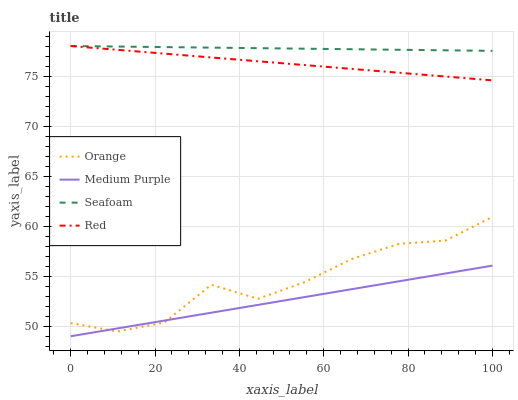Does Medium Purple have the minimum area under the curve?
Answer yes or no. Yes. Does Seafoam have the maximum area under the curve?
Answer yes or no. Yes. Does Seafoam have the minimum area under the curve?
Answer yes or no. No. Does Medium Purple have the maximum area under the curve?
Answer yes or no. No. Is Seafoam the smoothest?
Answer yes or no. Yes. Is Orange the roughest?
Answer yes or no. Yes. Is Medium Purple the smoothest?
Answer yes or no. No. Is Medium Purple the roughest?
Answer yes or no. No. Does Seafoam have the lowest value?
Answer yes or no. No. Does Red have the highest value?
Answer yes or no. Yes. Does Medium Purple have the highest value?
Answer yes or no. No. Is Medium Purple less than Seafoam?
Answer yes or no. Yes. Is Red greater than Medium Purple?
Answer yes or no. Yes. Does Medium Purple intersect Seafoam?
Answer yes or no. No. 